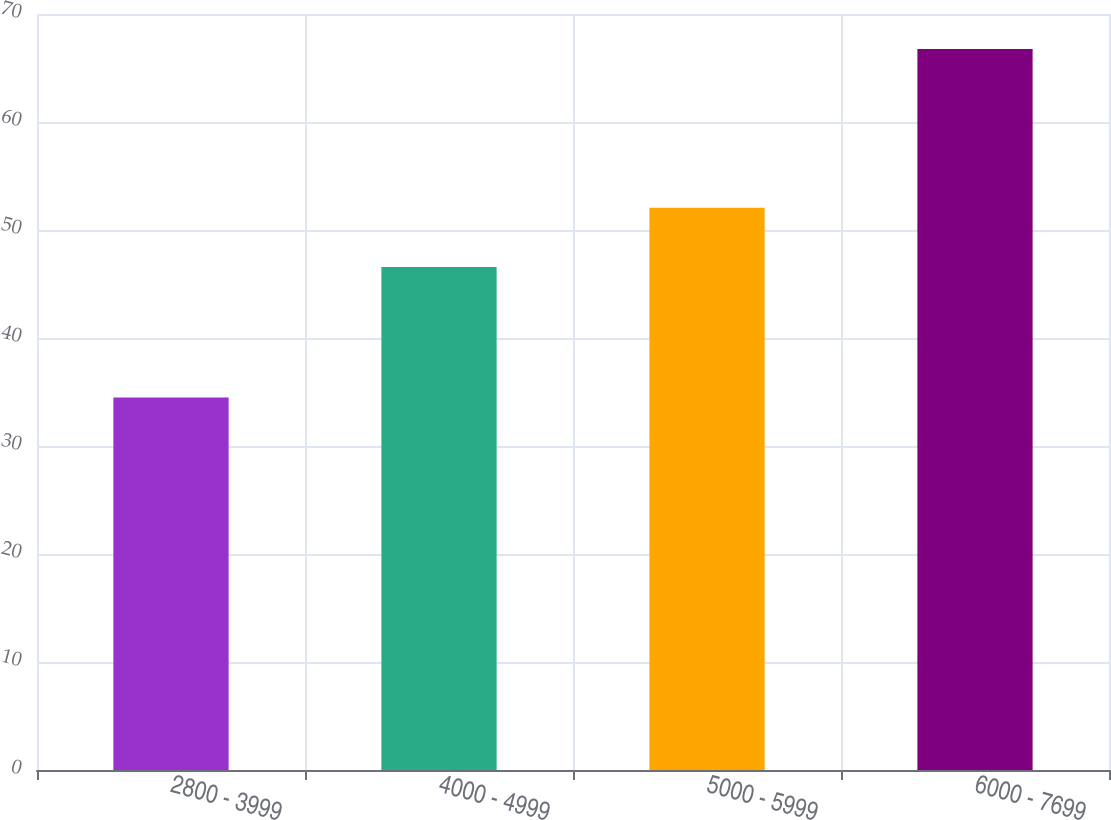<chart> <loc_0><loc_0><loc_500><loc_500><bar_chart><fcel>2800 - 3999<fcel>4000 - 4999<fcel>5000 - 5999<fcel>6000 - 7699<nl><fcel>34.5<fcel>46.57<fcel>52.05<fcel>66.75<nl></chart> 